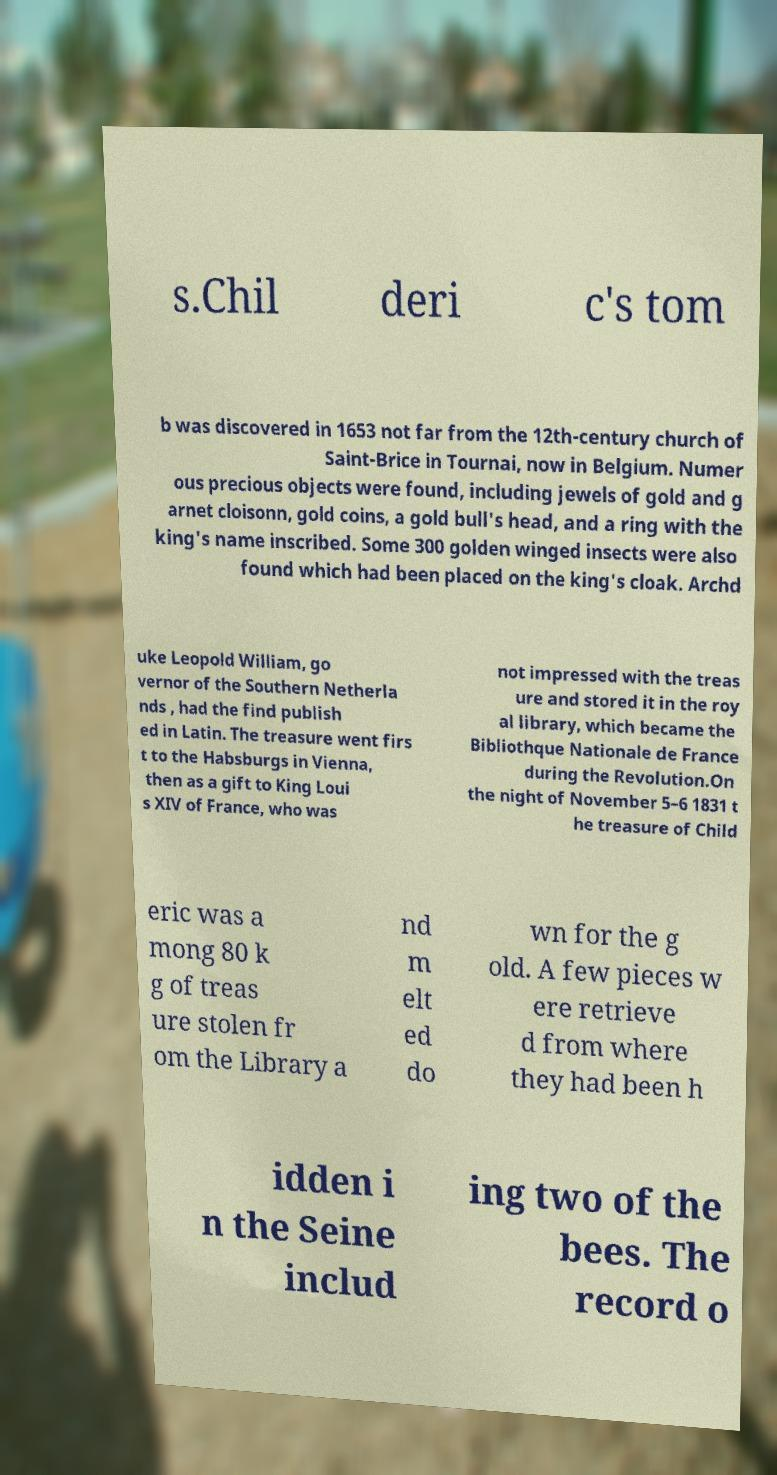I need the written content from this picture converted into text. Can you do that? s.Chil deri c's tom b was discovered in 1653 not far from the 12th-century church of Saint-Brice in Tournai, now in Belgium. Numer ous precious objects were found, including jewels of gold and g arnet cloisonn, gold coins, a gold bull's head, and a ring with the king's name inscribed. Some 300 golden winged insects were also found which had been placed on the king's cloak. Archd uke Leopold William, go vernor of the Southern Netherla nds , had the find publish ed in Latin. The treasure went firs t to the Habsburgs in Vienna, then as a gift to King Loui s XIV of France, who was not impressed with the treas ure and stored it in the roy al library, which became the Bibliothque Nationale de France during the Revolution.On the night of November 5–6 1831 t he treasure of Child eric was a mong 80 k g of treas ure stolen fr om the Library a nd m elt ed do wn for the g old. A few pieces w ere retrieve d from where they had been h idden i n the Seine includ ing two of the bees. The record o 